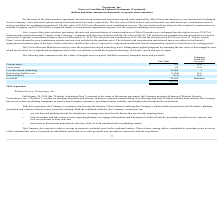According to Proofpoint's financial document, What method was used to value the acquired developed technology asset?  Cost to Recreate Method. The document states: "The Cost to Recreate Method was used to value the acquired developed technology asset. Management applied judgment in estimatin..." Also, Which subject has the highest estimated useful life? According to the financial document, Goodwill. The relevant text states: "Goodwill 85,869 Indefinite..." Also, What was the deferred cash consideration and deferred shares subjected to? forfeiture if employment terminates prior to the lapse of the restrictions, and their fair value is expensed as compensation and stock-based compensation expense over the three-year vesting period. The document states: "consideration and deferred shares are subject to forfeiture if employment terminates prior to the lapse of the restrictions, and their fair value is e..." Also, can you calculate: What is the difference in estimated fair value between current assets and fixed assets? Based on the calculation: $356 - 68, the result is 288 (in thousands). This is based on the information: "Current assets $ 356 N/A Fixed assets 68 N/A..." The key data points involved are: 356, 68. Also, can you calculate: What is the average estimated fair value of Core/developed technology? Based on the calculation: 21,000 / 3, the result is 7000 (in thousands). This is based on the information: "Core/developed technology 21,000 3 Core/developed technology 21,000 3..." The key data points involved are: 21,000, 3. Also, can you calculate: What is the total estimated fair value of all assets? Based on the calculation: $356 + 68 + 21,000, the result is 21424 (in thousands). This is based on the information: "Core/developed technology 21,000 3 Current assets $ 356 N/A Fixed assets 68 N/A..." The key data points involved are: 21,000, 356, 68. 